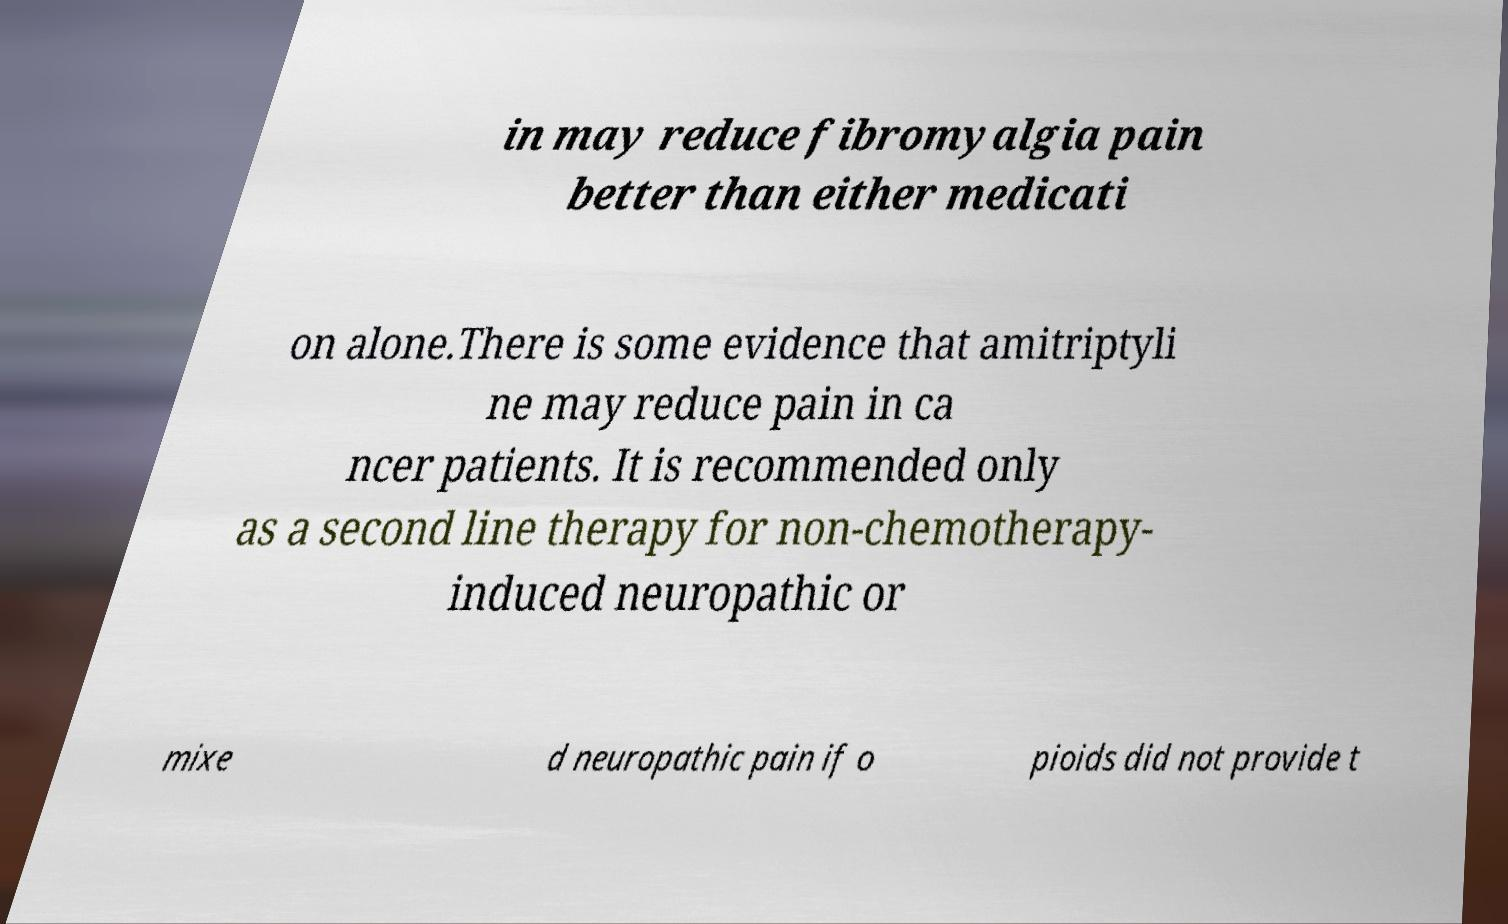Could you assist in decoding the text presented in this image and type it out clearly? in may reduce fibromyalgia pain better than either medicati on alone.There is some evidence that amitriptyli ne may reduce pain in ca ncer patients. It is recommended only as a second line therapy for non-chemotherapy- induced neuropathic or mixe d neuropathic pain if o pioids did not provide t 